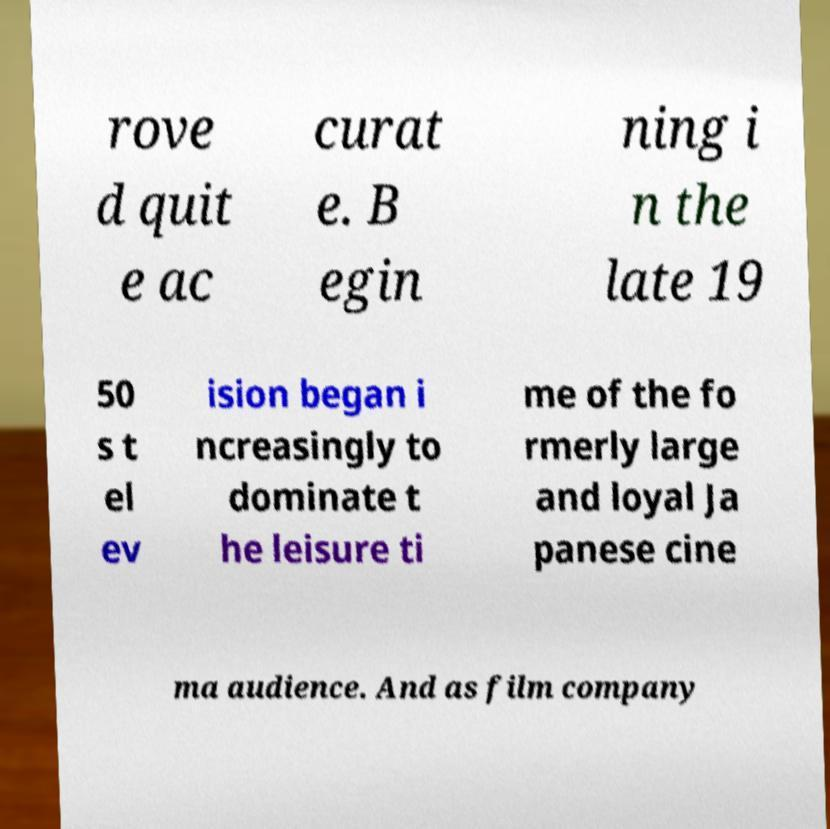What messages or text are displayed in this image? I need them in a readable, typed format. rove d quit e ac curat e. B egin ning i n the late 19 50 s t el ev ision began i ncreasingly to dominate t he leisure ti me of the fo rmerly large and loyal Ja panese cine ma audience. And as film company 